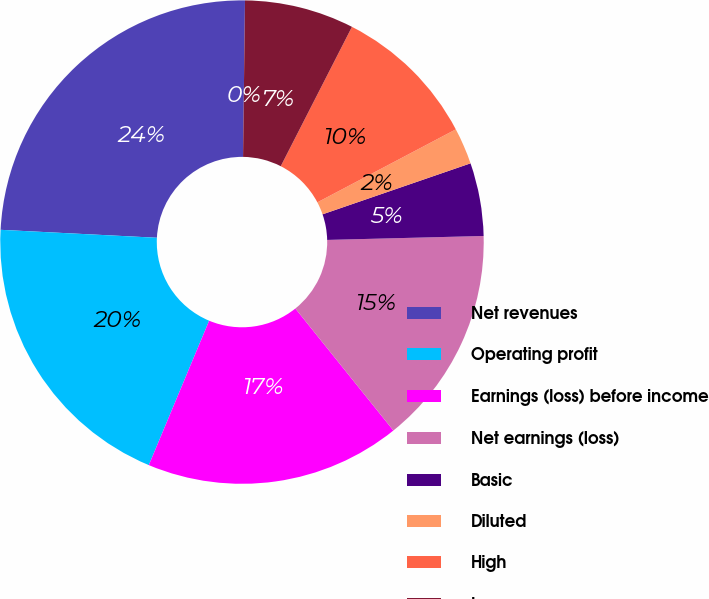Convert chart. <chart><loc_0><loc_0><loc_500><loc_500><pie_chart><fcel>Net revenues<fcel>Operating profit<fcel>Earnings (loss) before income<fcel>Net earnings (loss)<fcel>Basic<fcel>Diluted<fcel>High<fcel>Low<fcel>Cash dividends declared<nl><fcel>24.39%<fcel>19.51%<fcel>17.07%<fcel>14.63%<fcel>4.88%<fcel>2.44%<fcel>9.76%<fcel>7.32%<fcel>0.0%<nl></chart> 